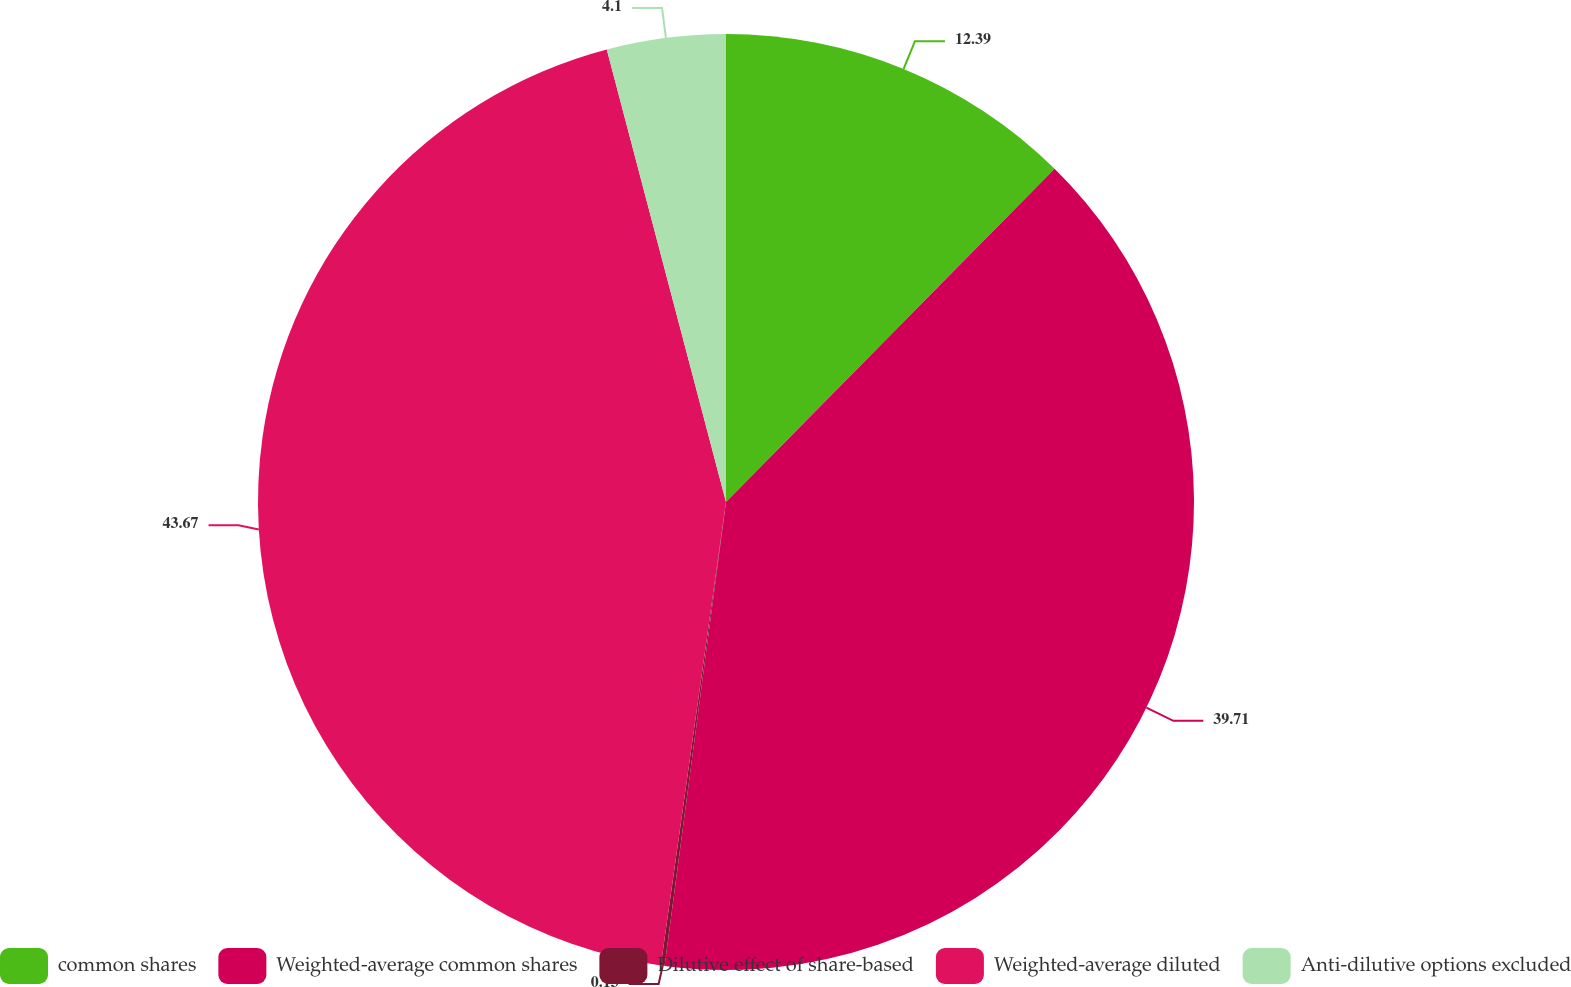Convert chart to OTSL. <chart><loc_0><loc_0><loc_500><loc_500><pie_chart><fcel>common shares<fcel>Weighted-average common shares<fcel>Dilutive effect of share-based<fcel>Weighted-average diluted<fcel>Anti-dilutive options excluded<nl><fcel>12.39%<fcel>39.71%<fcel>0.13%<fcel>43.68%<fcel>4.1%<nl></chart> 